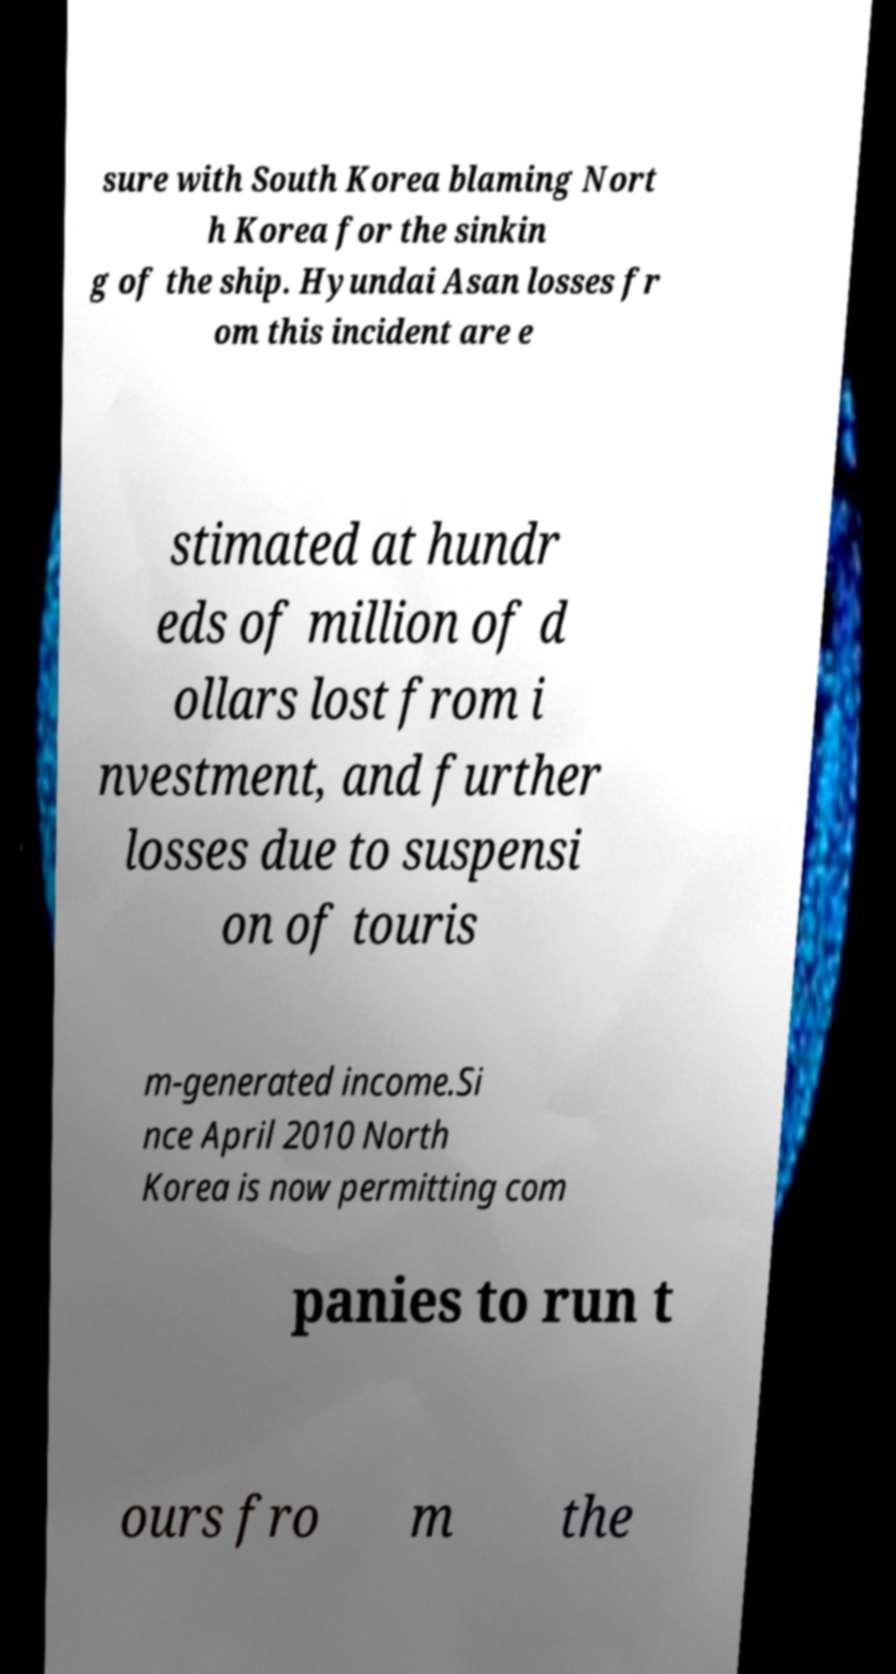I need the written content from this picture converted into text. Can you do that? sure with South Korea blaming Nort h Korea for the sinkin g of the ship. Hyundai Asan losses fr om this incident are e stimated at hundr eds of million of d ollars lost from i nvestment, and further losses due to suspensi on of touris m-generated income.Si nce April 2010 North Korea is now permitting com panies to run t ours fro m the 